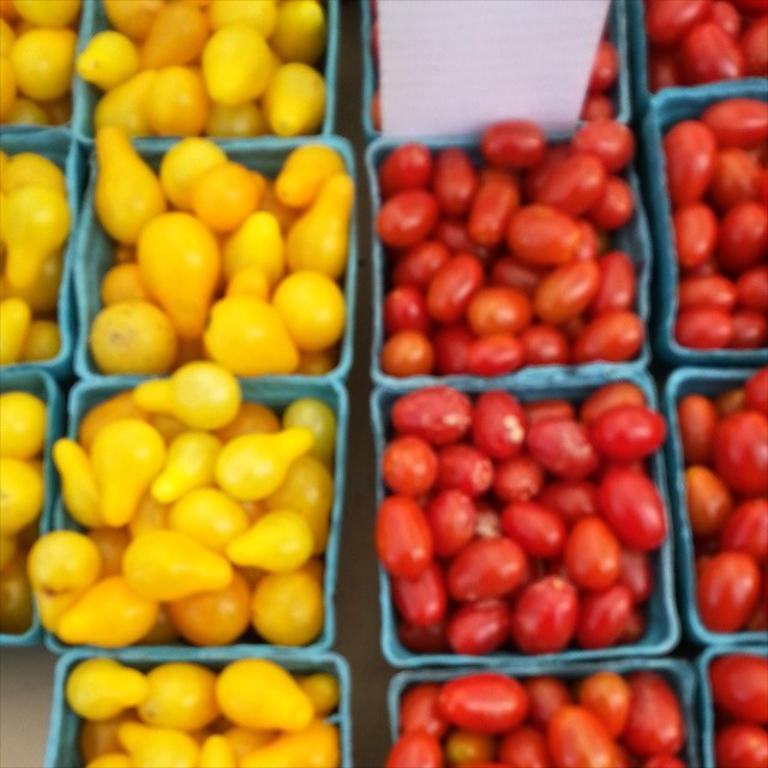What types of food items can be seen in the image? There are different types of fruits in the image. How are the fruits organized in the image? The fruits are arranged in baskets. What type of hammer is used to create the coil seen in the image? There is no hammer, steel, or coil present in the image; it only features different types of fruits arranged in baskets. 